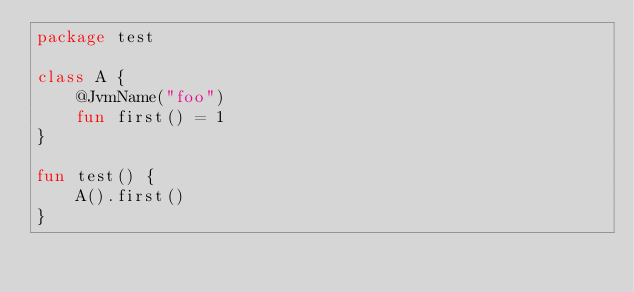Convert code to text. <code><loc_0><loc_0><loc_500><loc_500><_Kotlin_>package test

class A {
    @JvmName("foo")
    fun first() = 1
}

fun test() {
    A().first()
}</code> 